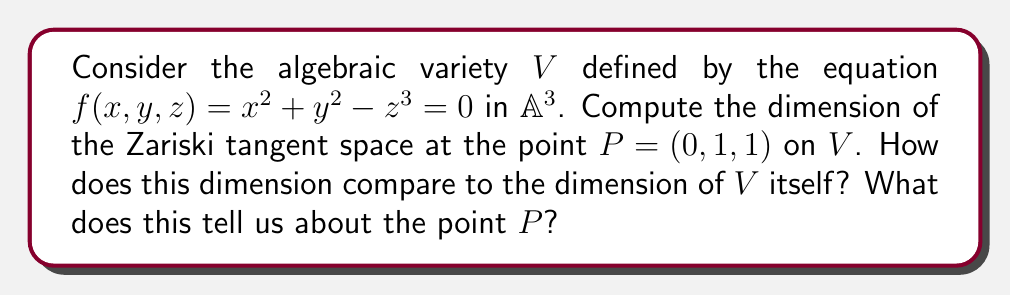Provide a solution to this math problem. Let's approach this step-by-step:

1) The Zariski tangent space at a point $P$ on an algebraic variety $V$ is defined as the vector space dual to $\mathfrak{m}_P/\mathfrak{m}_P^2$, where $\mathfrak{m}_P$ is the maximal ideal of the local ring at $P$.

2) For an affine variety defined by a single equation $f=0$, the dimension of the Zariski tangent space at a point $P$ is equal to $n - \text{rank}(J_f(P))$, where $n$ is the dimension of the ambient space and $J_f(P)$ is the Jacobian matrix of $f$ evaluated at $P$.

3) In our case, $n=3$ (as we're in $\mathbb{A}^3$), and we need to compute $J_f(P)$:

   $J_f = [\frac{\partial f}{\partial x}, \frac{\partial f}{\partial y}, \frac{\partial f}{\partial z}] = [2x, 2y, -3z^2]$

4) Evaluating at $P=(0,1,1)$:

   $J_f(P) = [0, 2, -3]$

5) The rank of this matrix is 1, as it has one non-zero row.

6) Therefore, the dimension of the Zariski tangent space at $P$ is:

   $\dim T_P V = 3 - \text{rank}(J_f(P)) = 3 - 1 = 2$

7) The dimension of $V$ itself is 2, as it's defined by a single equation in $\mathbb{A}^3$.

8) Since the dimension of the Zariski tangent space equals the dimension of $V$, we can conclude that $P$ is a smooth point on $V$.
Answer: $\dim T_P V = 2$; equal to $\dim V$; $P$ is smooth. 